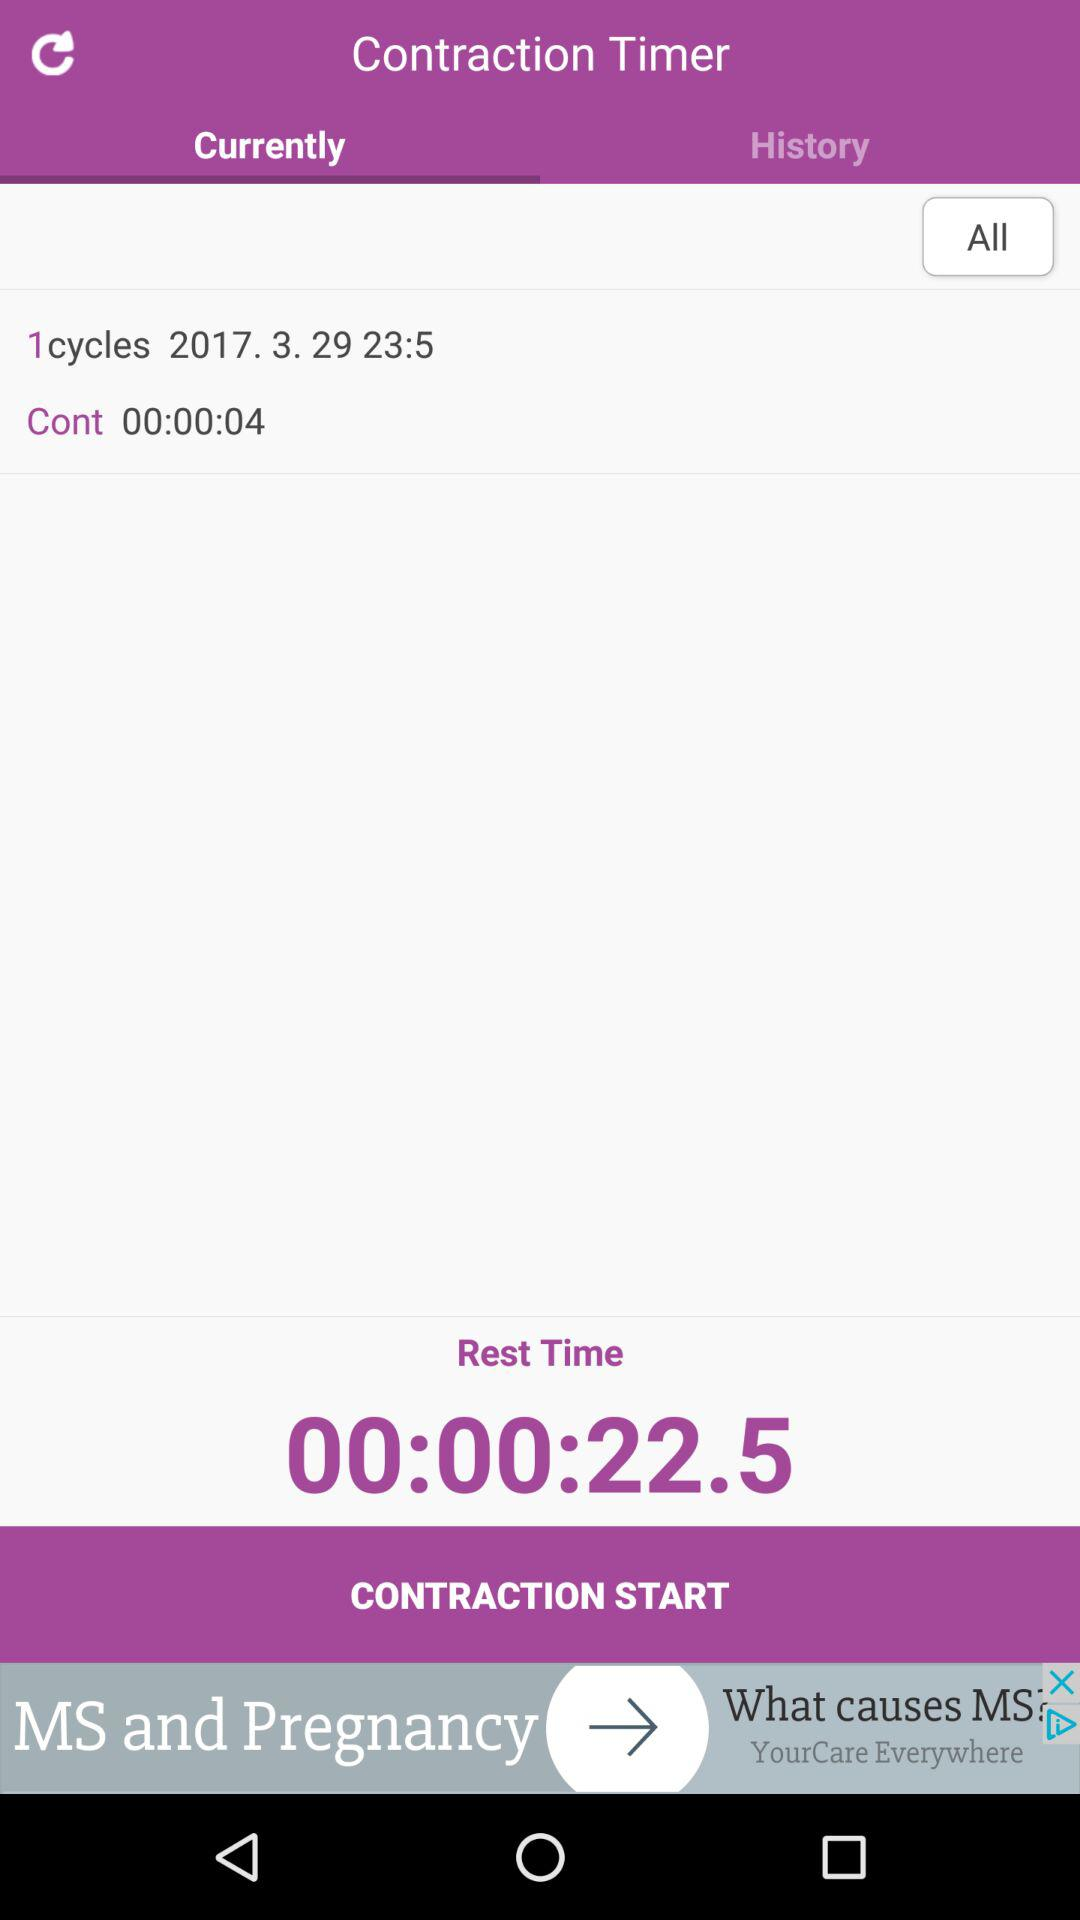What is the rest time? The rest time is 22.5 seconds. 